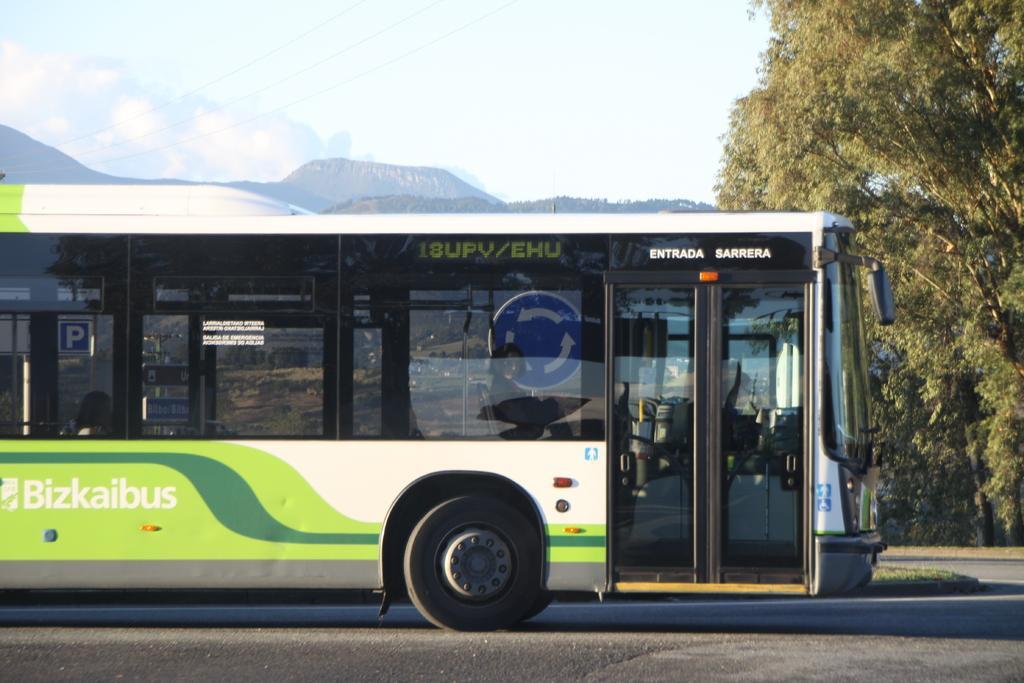Could you give a brief overview of what you see in this image? On the left side, there is a bus having glass windows, on a road. On the right side, there are trees. In the background, there are mountains and there are clouds in the sky. 